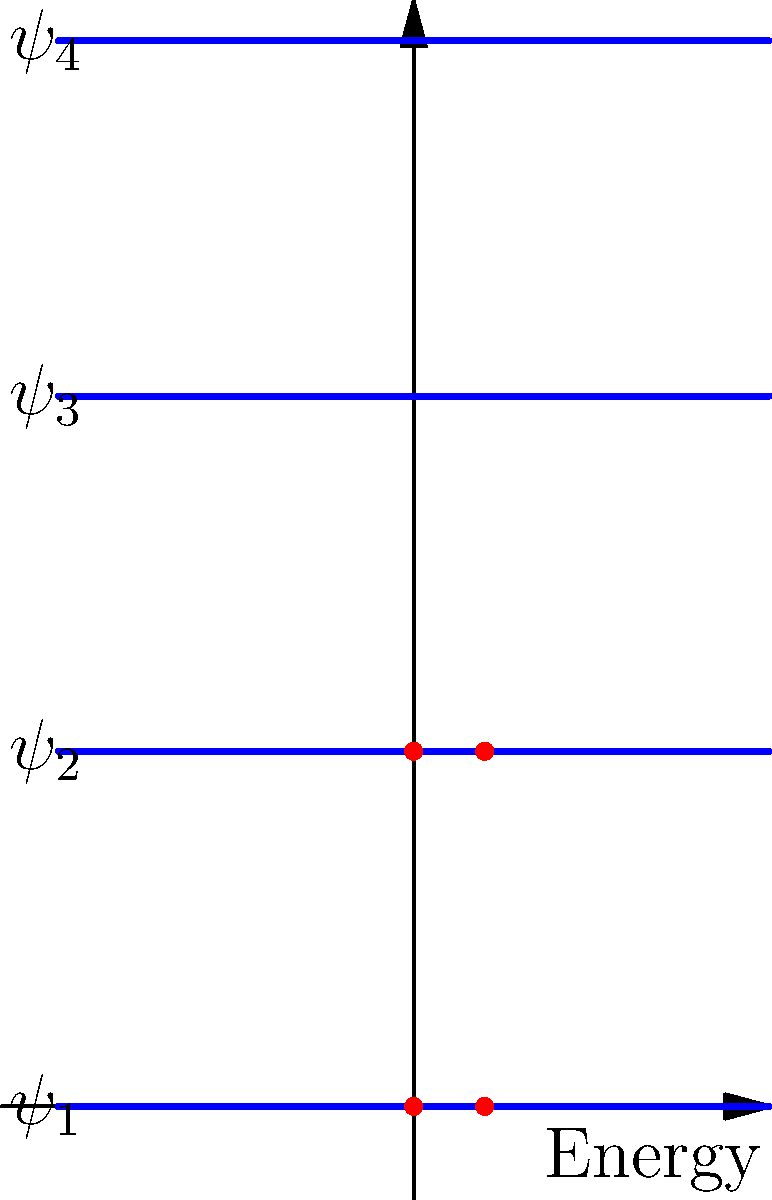Analyze the molecular orbital diagram of a conjugated system shown above. If this represents the π-electron system of 1,3-butadiene, what is the HOMO-LUMO gap energy in terms of β (the resonance integral)? To determine the HOMO-LUMO gap energy for 1,3-butadiene:

1. Identify the orbitals:
   - The diagram shows 4 π-molecular orbitals ($\psi_1$ to $\psi_4$).
   - There are 4 π-electrons (2 from each double bond).

2. Electron filling:
   - The electrons occupy the lowest energy orbitals first.
   - $\psi_1$ and $\psi_2$ are fully occupied (HOMO).
   - $\psi_3$ is empty (LUMO).

3. Energy levels in Hückel theory:
   For 1,3-butadiene, the energies are:
   $E_1 = \alpha + 1.618\beta$
   $E_2 = \alpha + 0.618\beta$
   $E_3 = \alpha - 0.618\beta$
   $E_4 = \alpha - 1.618\beta$
   where $\alpha$ is the Coulomb integral and $\beta$ is the resonance integral.

4. HOMO-LUMO gap calculation:
   Gap = $E_{\text{LUMO}} - E_{\text{HOMO}}$
       = $E_3 - E_2$
       = $(\alpha - 0.618\beta) - (\alpha + 0.618\beta)$
       = $-1.236\beta$

Therefore, the HOMO-LUMO gap energy is $1.236\beta$.
Answer: $1.236\beta$ 